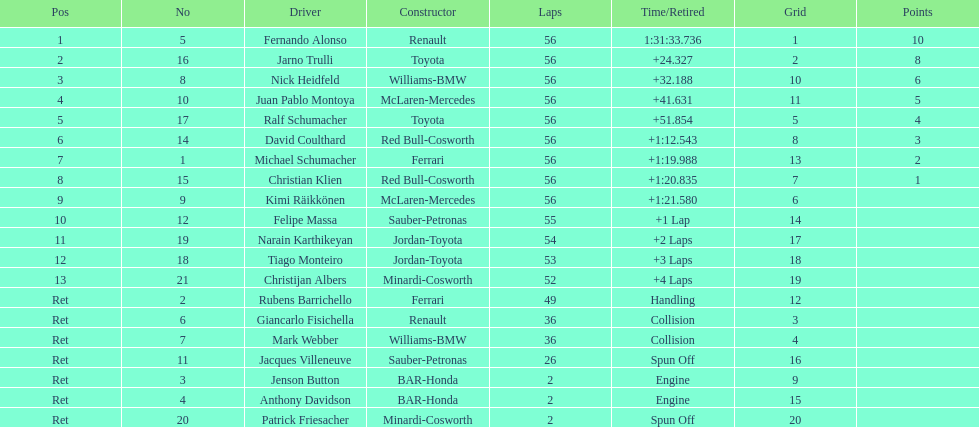How long did it take for heidfeld to finish? 1:31:65.924. 